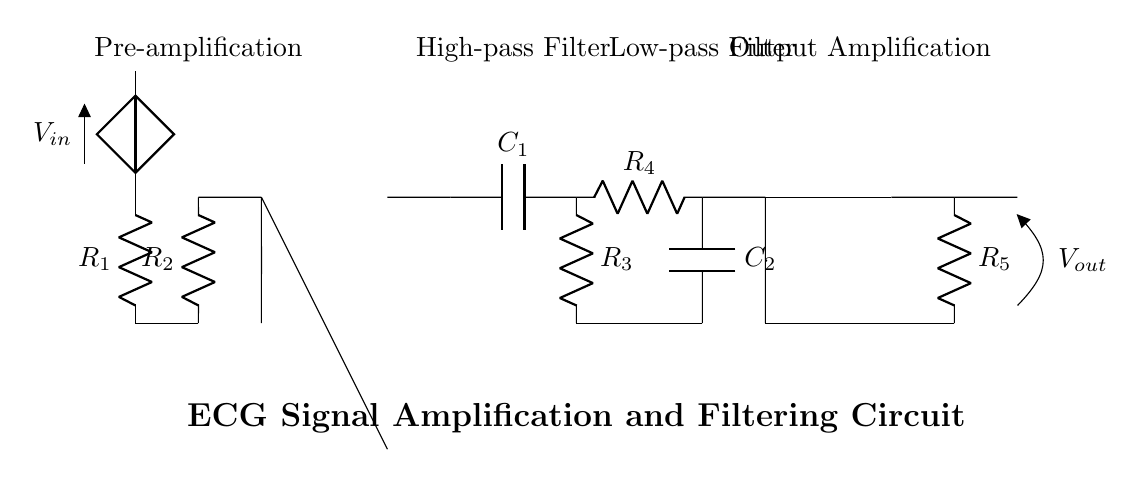What is the input voltage symbol in the circuit? The input voltage is represented by the symbol V_in, which is shown connected to the circuit at the pre-amplification stage.
Answer: V_in What is the function of R_2 in the circuit? R_2 is connected in series between the input voltage and the operational amplifier, serving as part of the input resistive network to determine gain and impedance.
Answer: Gain and impedance How many operational amplifiers are used in this circuit? There are two operational amplifiers present in the circuit diagram, one for pre-amplification and another for output amplification.
Answer: Two What type of filters are implemented in the circuit? The circuit includes both a high-pass filter and a low-pass filter, indicated by the arrangements of the capacitors and resistors.
Answer: High-pass and low-pass What is the role of C_1 in this circuit? C_1 is part of the high-pass filter, allowing high-frequency signals to pass while attenuating low-frequency noise which is essential for clear ECG signal detection.
Answer: High-frequency attenuation What is the output voltage symbol shown in the circuit? The output voltage is denoted by the symbol V_out, which is located at the end of the output amplification stage.
Answer: V_out What is the significance of R_5 in the output amplification stage? R_5 is the feedback resistor in the output amplification stage, which helps to set the gain of the operational amplifier, thus influencing the final output signal level.
Answer: Gain setting 